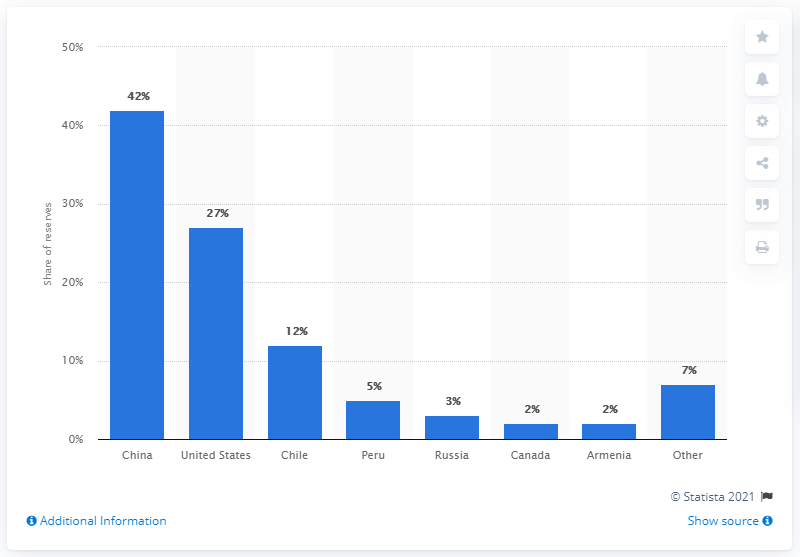Can you explain the significance of molybdenum in the global market? Certainly, molybdenum is a valuable industrial metal known for its high strength and resistance to heat and corrosion. It's critically important in the manufacture of high-strength steel alloys, electronics, and as a catalyst in the oil refining industry. The distribution of molybdenum reserves is significant as it affects global trade, pricing, and the strategic planning of industries that rely on this element. Countries with the largest reserves, such as China, play a key role in the supply and thus have a substantial influence over the global market. 